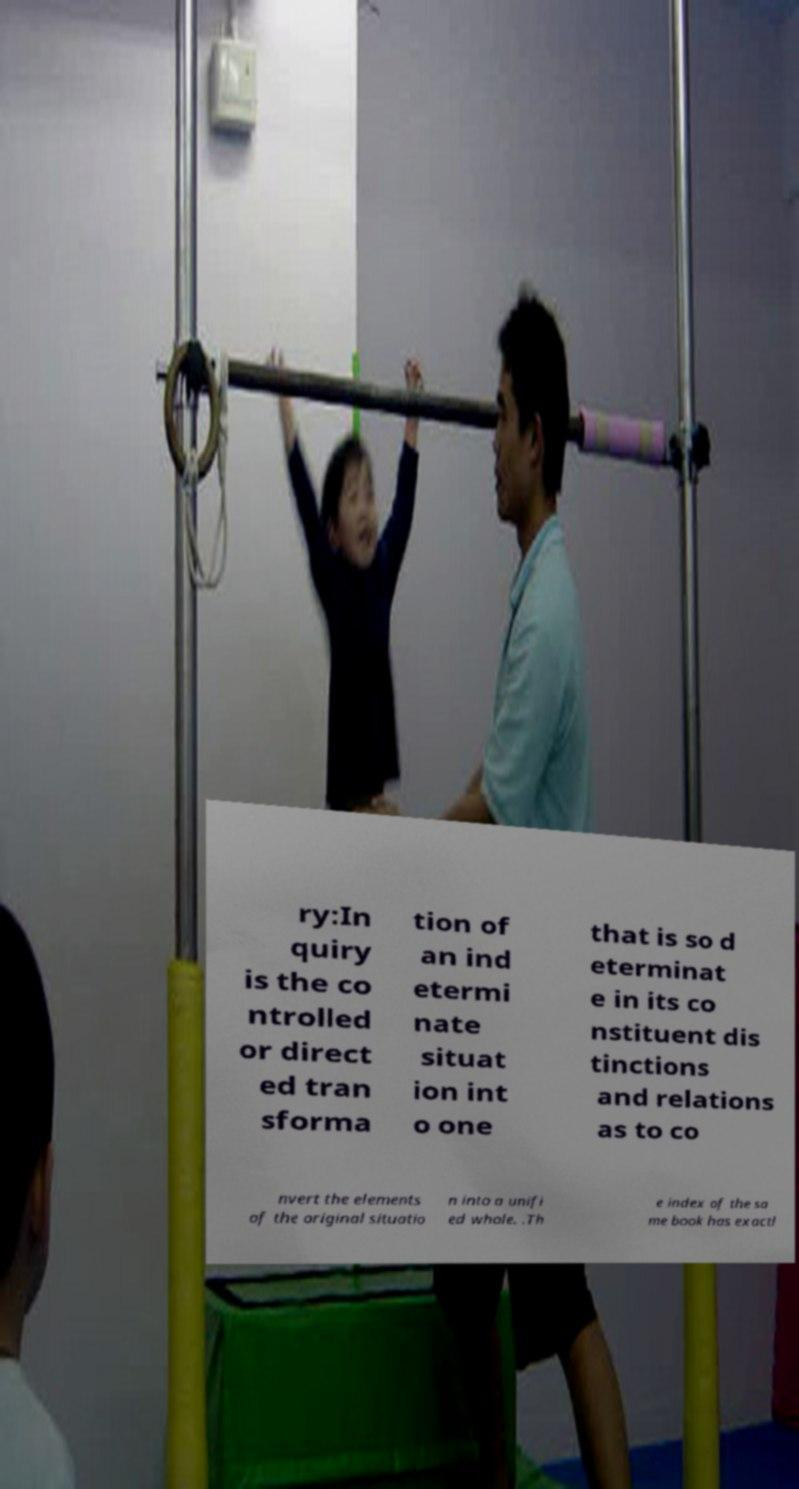Could you assist in decoding the text presented in this image and type it out clearly? ry:In quiry is the co ntrolled or direct ed tran sforma tion of an ind etermi nate situat ion int o one that is so d eterminat e in its co nstituent dis tinctions and relations as to co nvert the elements of the original situatio n into a unifi ed whole. .Th e index of the sa me book has exactl 